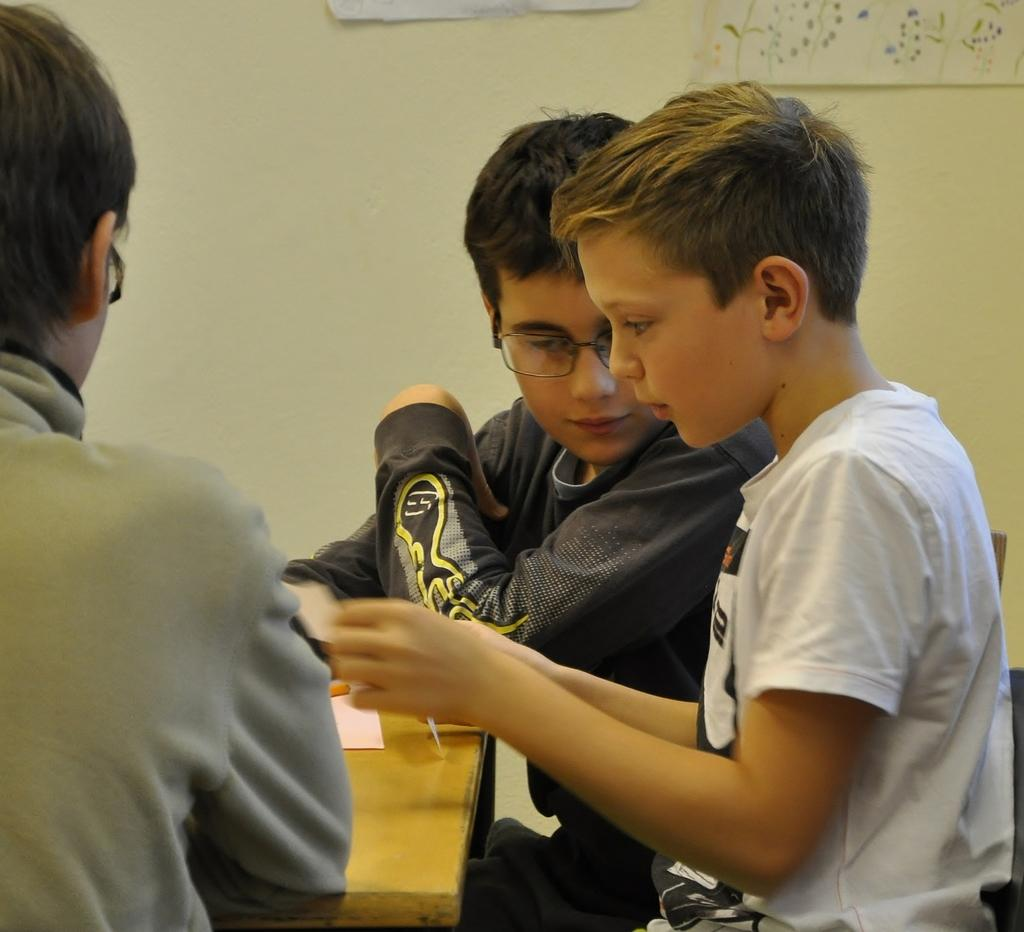How many people are in the image? There are a few people in the image. What is one person doing in the image? One person is holding an object. What can be seen on the wall in the image? There is a wall with posters in the image. What type of object is made of wood in the image? There is a wooden object in the image. What time of day is it in the image, specifically in the afternoon? The time of day is not mentioned in the image, so it cannot be determined if it is specifically in the afternoon. How does the person holding the object control the sneeze in the image? There is no sneeze or indication of a sneeze in the image, so it cannot be determined how the person might control it. 